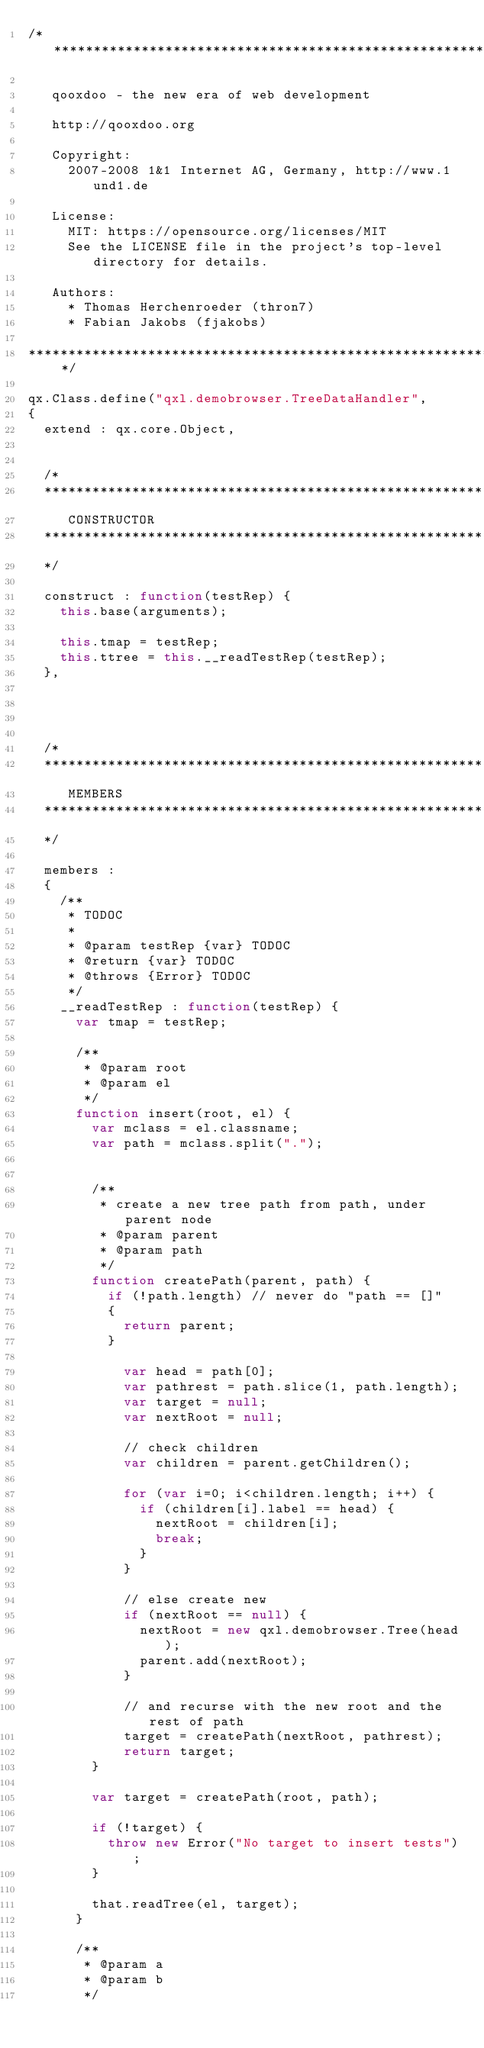<code> <loc_0><loc_0><loc_500><loc_500><_JavaScript_>/* ************************************************************************

   qooxdoo - the new era of web development

   http://qooxdoo.org

   Copyright:
     2007-2008 1&1 Internet AG, Germany, http://www.1und1.de

   License:
     MIT: https://opensource.org/licenses/MIT
     See the LICENSE file in the project's top-level directory for details.

   Authors:
     * Thomas Herchenroeder (thron7)
     * Fabian Jakobs (fjakobs)

************************************************************************ */

qx.Class.define("qxl.demobrowser.TreeDataHandler",
{
  extend : qx.core.Object,


  /*
  *****************************************************************************
     CONSTRUCTOR
  *****************************************************************************
  */

  construct : function(testRep) {
    this.base(arguments);

    this.tmap = testRep;
    this.ttree = this.__readTestRep(testRep);
  },




  /*
  *****************************************************************************
     MEMBERS
  *****************************************************************************
  */

  members :
  {
    /**
     * TODOC
     *
     * @param testRep {var} TODOC
     * @return {var} TODOC
     * @throws {Error} TODOC
     */
    __readTestRep : function(testRep) {
      var tmap = testRep;

      /**
       * @param root
       * @param el
       */
      function insert(root, el) {
        var mclass = el.classname;
        var path = mclass.split(".");


        /**
         * create a new tree path from path, under parent node
         * @param parent
         * @param path
         */
        function createPath(parent, path) {
          if (!path.length) // never do "path == []"
          {
            return parent;
          }
          
            var head = path[0];
            var pathrest = path.slice(1, path.length);
            var target = null;
            var nextRoot = null;

            // check children
            var children = parent.getChildren();

            for (var i=0; i<children.length; i++) {
              if (children[i].label == head) {
                nextRoot = children[i];
                break;
              }
            }

            // else create new
            if (nextRoot == null) {
              nextRoot = new qxl.demobrowser.Tree(head);
              parent.add(nextRoot);
            }

            // and recurse with the new root and the rest of path
            target = createPath(nextRoot, pathrest);
            return target;
        }

        var target = createPath(root, path);

        if (!target) {
          throw new Error("No target to insert tests");
        }

        that.readTree(el, target);
      }

      /**
       * @param a
       * @param b
       */</code> 